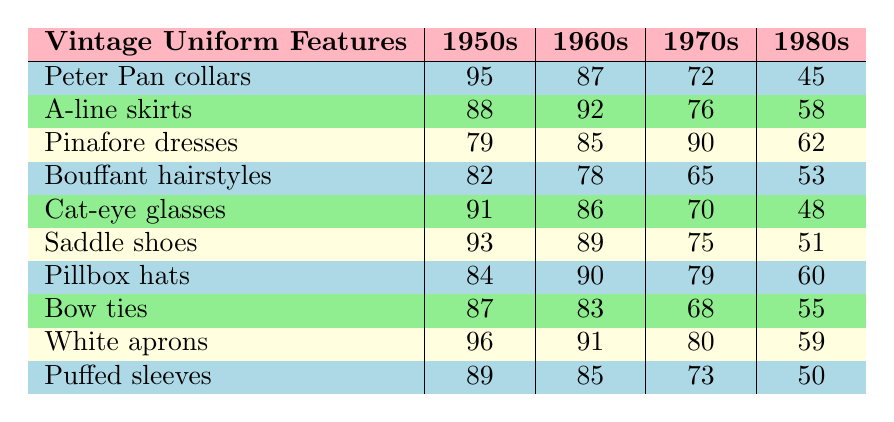What is the popularity score for Peter Pan collars in the 1960s? Referring to the table, under "Peter Pan collars" in the "1960s" column, the score is 87.
Answer: 87 Which vintage uniform feature has the highest popularity score in the 1950s? Looking through the 1950s column, "White aprons" has the highest score of 96.
Answer: White aprons Calculate the average popularity score for A-line skirts across all decades. The scores for A-line skirts are 88 (1950s), 92 (1960s), 76 (1970s), and 58 (1980s). The total is 88 + 92 + 76 + 58 = 314. There are 4 scores, so the average is 314/4 = 78.5.
Answer: 78.5 Is the popularity score for cat-eye glasses higher than that of bouffant hairstyles in the 1970s? Cat-eye glasses have a score of 70, and bouffant hairstyles have a score of 65 in the 1970s, so yes, cat-eye glasses have a higher score.
Answer: Yes Identify the decade where Pinafore dresses score below 70. The scores for Pinafore dresses are 79 (1950s), 85 (1960s), 90 (1970s), and 62 (1980s). Since 62 is below 70, Pinafore dresses score below 70 in the 1980s.
Answer: 1980s What is the score difference between Saddle shoes in the 1950s and 1980s? Saddle shoes score 93 in the 1950s and 51 in the 1980s. The difference is 93 - 51 = 42.
Answer: 42 Among all the features, which has the lowest score in the 1980s, and what is that score? Checking the 1980s column, Puffed sleeves score 50, which is the lowest compared to other features.
Answer: Puffed sleeves; 50 Do more vintage uniform features score above 80 in the 1960s or in the 1970s? In the 1960s, Peter Pan collars (87), A-line skirts (92), Pinafore dresses (85), Cat-eye glasses (86), Saddle shoes (89), Pillbox hats (90), and Bow ties (83) all score above 80, totaling 7 features. In the 1970s, only Pinafore dresses (90), Saddle shoes (75), Pillbox hats (79), and White aprons (80) score above 80, totaling 4 features. Therefore, more features score above 80 in the 1960s.
Answer: 1960s What is the total popularity score for all features combined in the 1950s? Adding the scores for all features in the 1950s gives: 95 + 88 + 79 + 82 + 91 + 93 + 84 + 87 + 96 + 89 = 894.
Answer: 894 